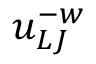Convert formula to latex. <formula><loc_0><loc_0><loc_500><loc_500>u _ { L J } ^ { - w }</formula> 